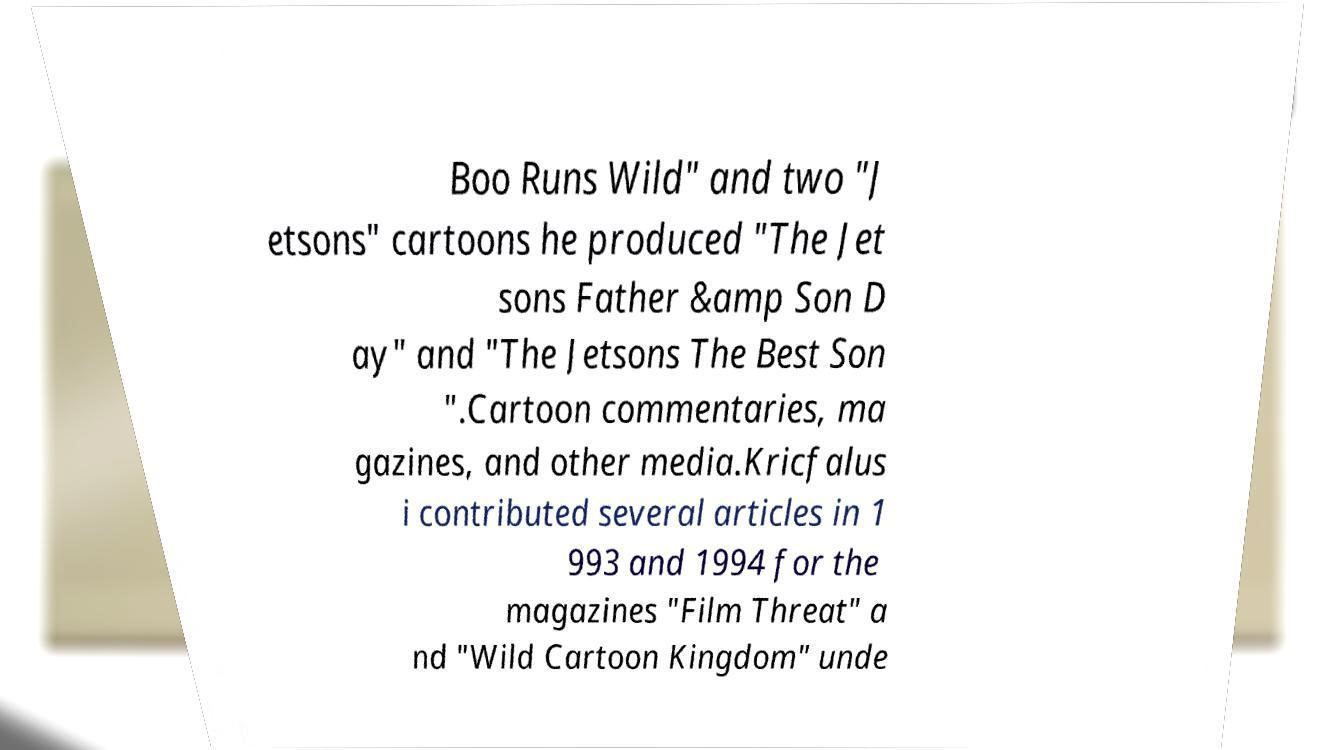There's text embedded in this image that I need extracted. Can you transcribe it verbatim? Boo Runs Wild" and two "J etsons" cartoons he produced "The Jet sons Father &amp Son D ay" and "The Jetsons The Best Son ".Cartoon commentaries, ma gazines, and other media.Kricfalus i contributed several articles in 1 993 and 1994 for the magazines "Film Threat" a nd "Wild Cartoon Kingdom" unde 